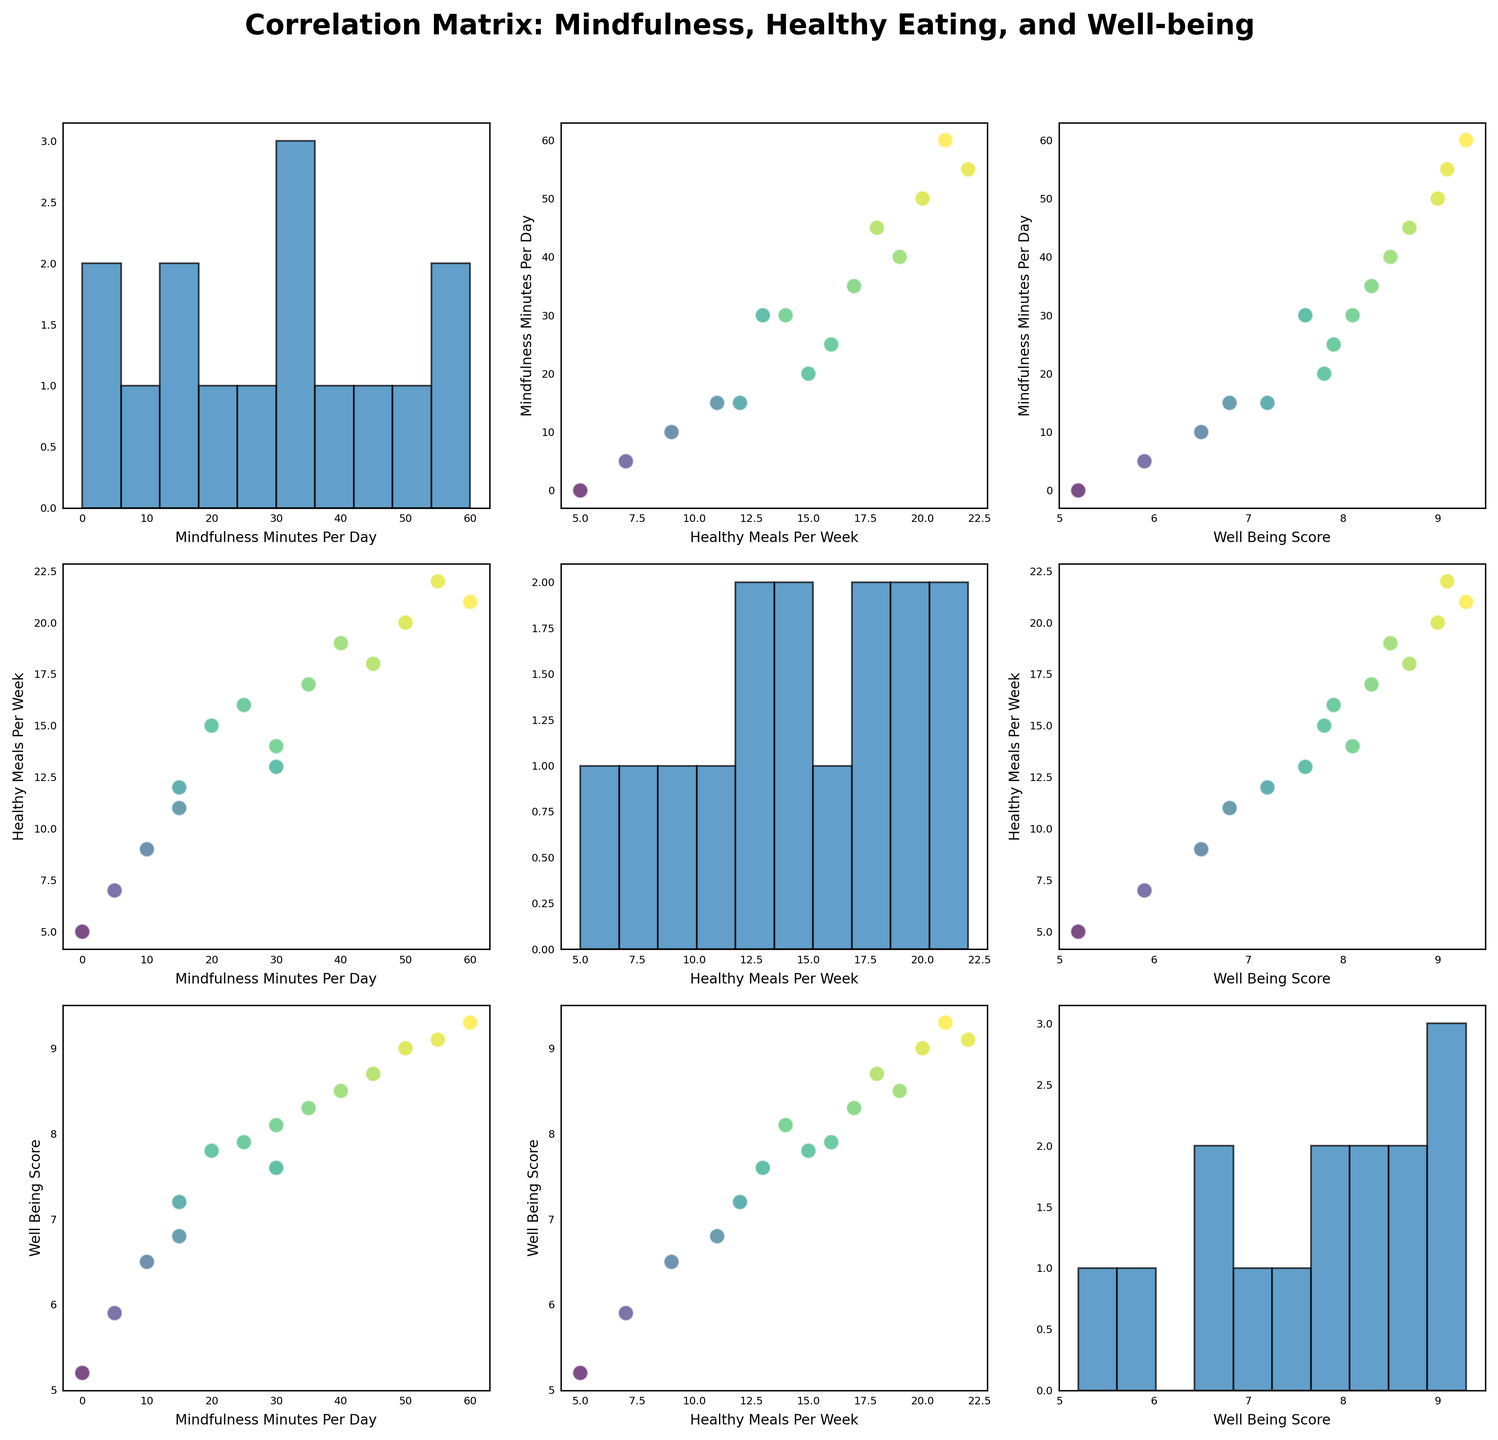What is the title of the figure? The title is usually located at the top of the figure, and it provides a summary of the content and purpose of the plot.
Answer: Correlation Matrix: Mindfulness, Healthy Eating, and Well-being How many variables are being compared in the scatterplot matrix? The scatterplot matrix typically compares multiple variables, and the number of variables can be counted by looking at the labels along the diagonal or the number of plots vertically and horizontally.
Answer: 3 Which variable pair shows a positive correlation with higher well-being scores highlighted in yellow? By observing the scatter plots where the color gradient (viridis) moves towards yellow, which indicates higher well-being scores, it is possible to identify which pairs are positively correlated.
Answer: Mindfulness Minutes Per Day and Healthy Meals Per Week What is the range of values for the 'Well-Being Score' based on the histogram(s) along the diagonal? By examining the histograms on the diagonal where 'Well-Being Score' is plotted, the range of values is indicated by the bins and the data distribution within those bins.
Answer: 5.2 to 9.3 What is the relationship between 'Mindfulness Minutes Per Day' and 'Well-Being Score' based on the scatter plots? To determine the relationship, observe the scatter plot where 'Mindfulness Minutes Per Day' is on one axis and 'Well-Being Score' is on the other. Note the direction and spreading of the data points.
Answer: Positive correlation Are any participants practicing zero minutes of mindfulness per day? If so, what are their well-being scores? Look for data points where 'Mindfulness Minutes Per Day' is zero and then check the corresponding 'Well-Being Score' for those points.
Answer: Yes, 5.2 How do 'Healthy Meals Per Week' and 'Mindfulness Minutes Per Day' impact the well-being scores according to the figure? Analyze the scatter plots and the color gradient indicating well-being scores to understand how changes in 'Healthy Meals Per Week' and 'Mindfulness Minutes Per Day' are associated with changes in 'Well-Being Score'. Consider both axes simultaneously.
Answer: Higher values in both are associated with higher well-being scores Comparing 'Mindfulness Minutes Per Day' and 'Healthy Meals Per Week', which one appears to have a stronger correlation with 'Well-Being Score'? Identify trends and patterns in scatter plots for each variable pair and their association with 'Well-Being Score'. A steeper or more distinct trend can suggest a stronger correlation.
Answer: Healthy Meals Per Week What seems to be the lowest well-being score, based on the histogram? Check the lower end of the bins in the histogram labeled 'Well-Being Score' for the minimum value.
Answer: 5.2 